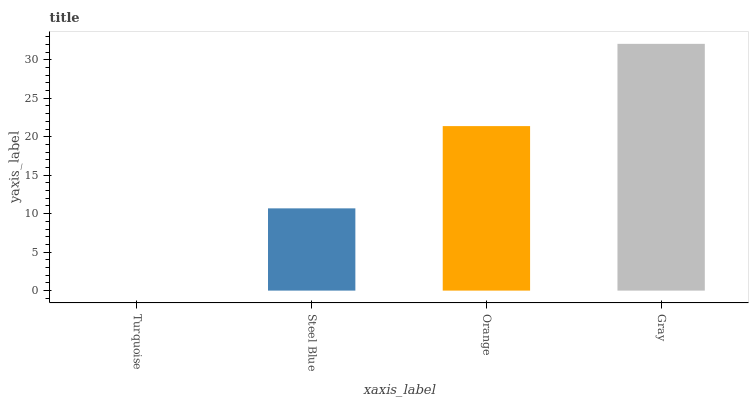Is Turquoise the minimum?
Answer yes or no. Yes. Is Gray the maximum?
Answer yes or no. Yes. Is Steel Blue the minimum?
Answer yes or no. No. Is Steel Blue the maximum?
Answer yes or no. No. Is Steel Blue greater than Turquoise?
Answer yes or no. Yes. Is Turquoise less than Steel Blue?
Answer yes or no. Yes. Is Turquoise greater than Steel Blue?
Answer yes or no. No. Is Steel Blue less than Turquoise?
Answer yes or no. No. Is Orange the high median?
Answer yes or no. Yes. Is Steel Blue the low median?
Answer yes or no. Yes. Is Steel Blue the high median?
Answer yes or no. No. Is Gray the low median?
Answer yes or no. No. 